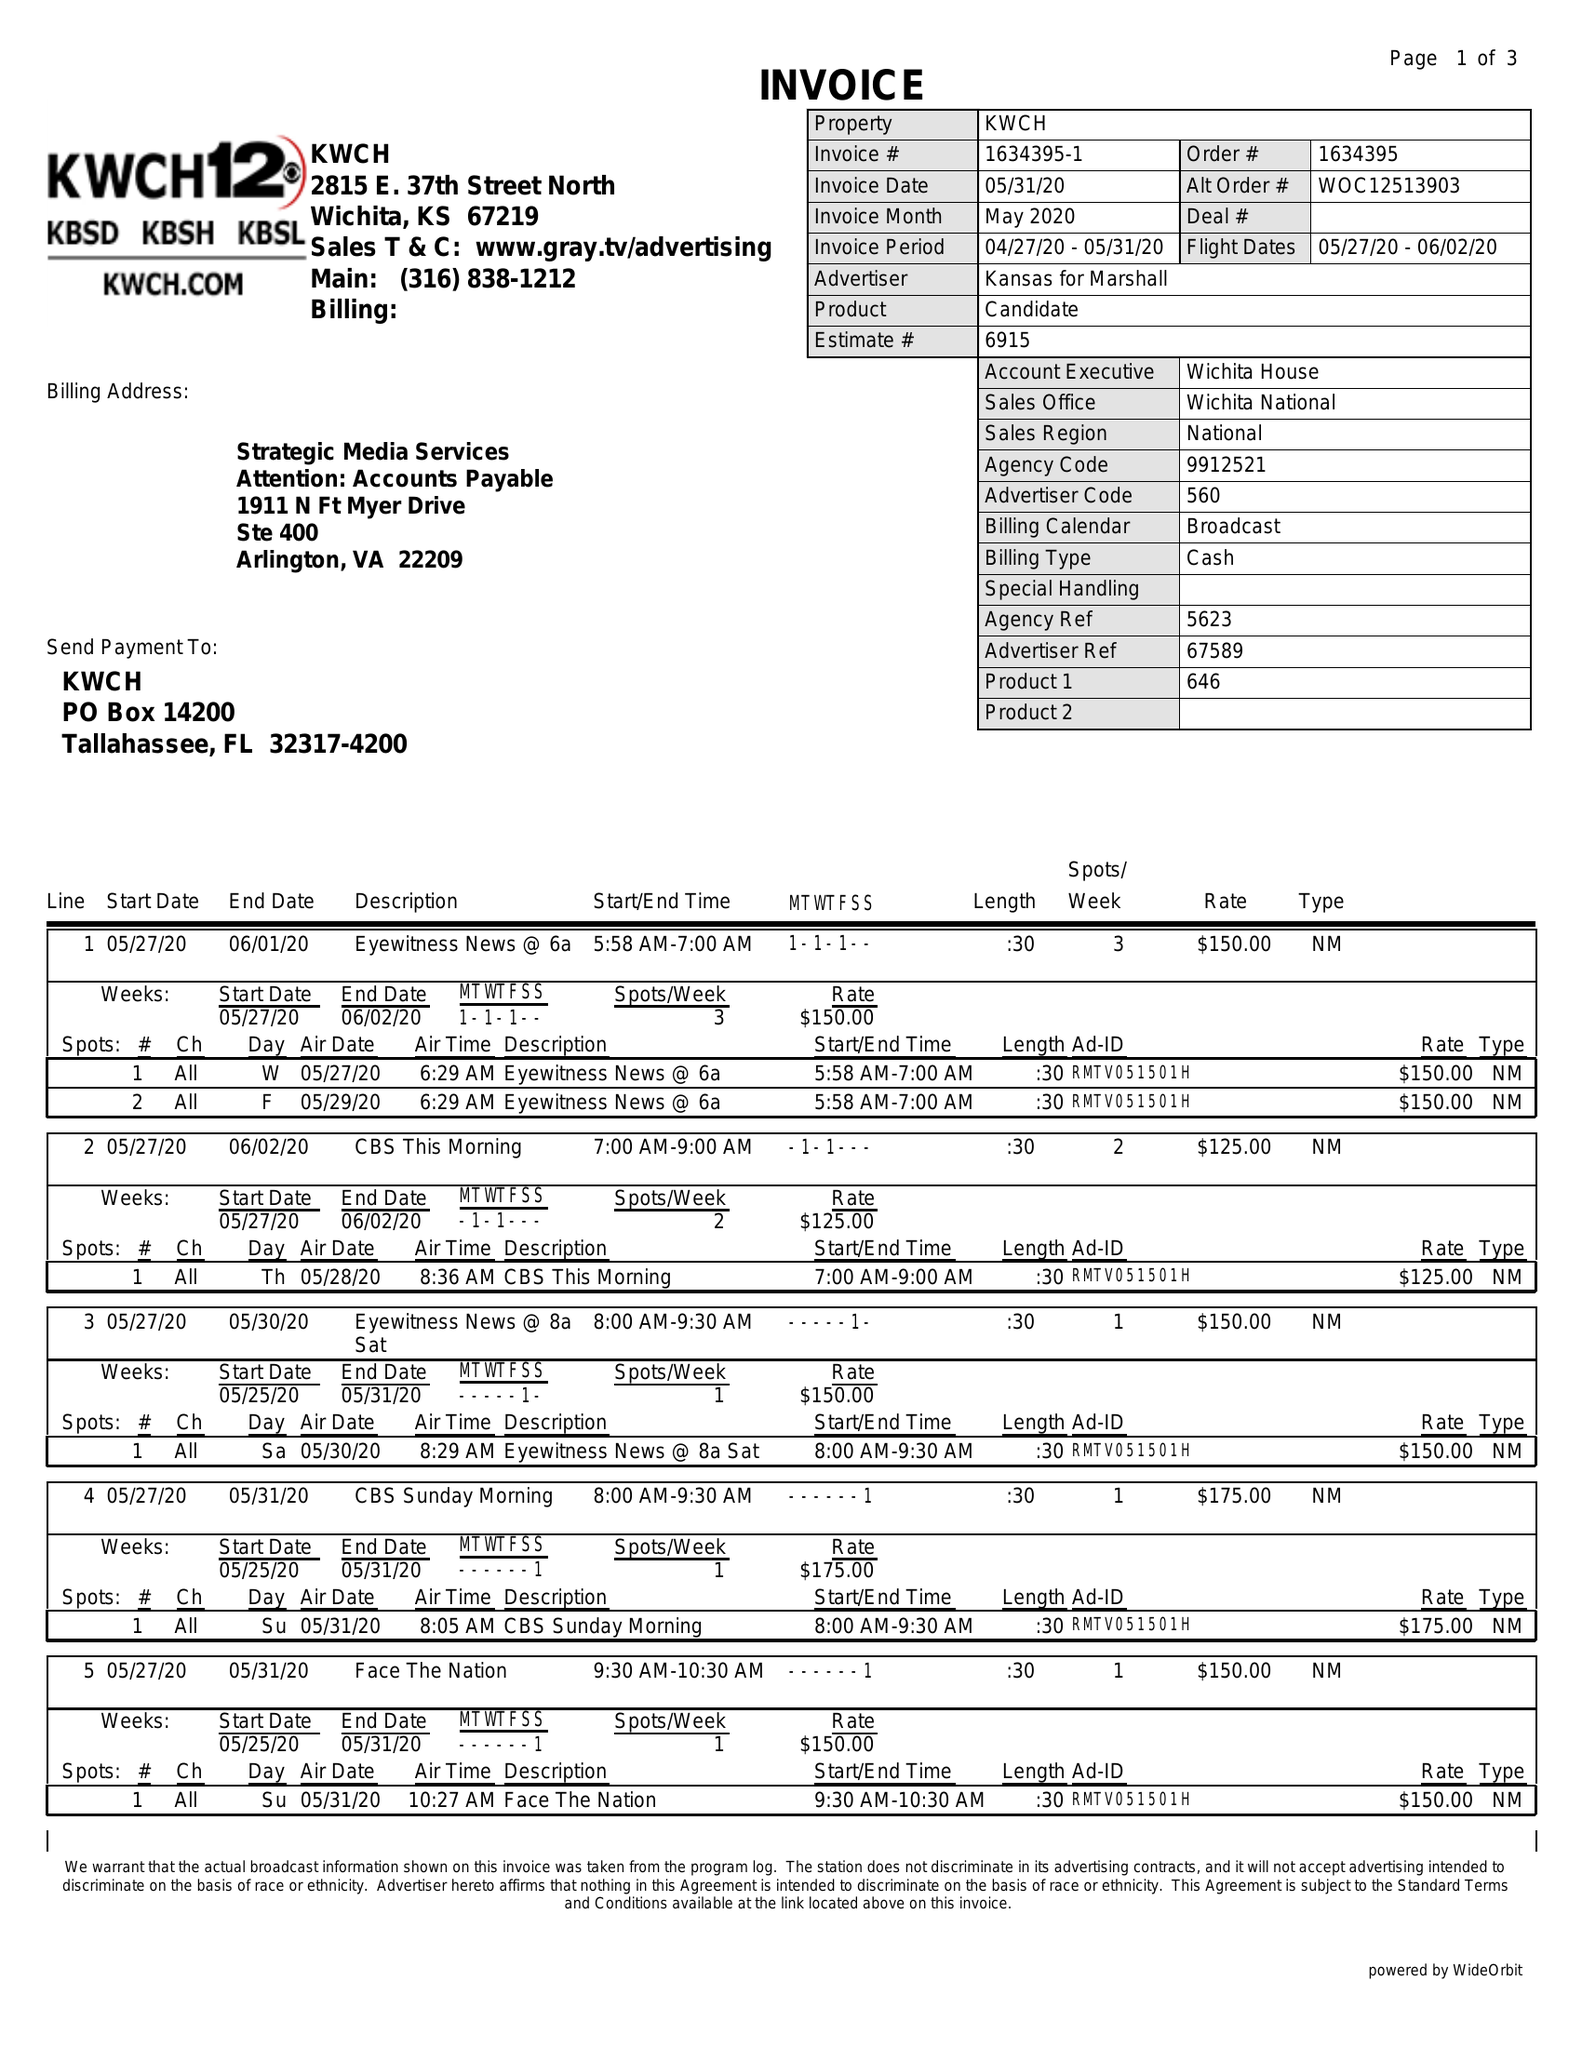What is the value for the flight_to?
Answer the question using a single word or phrase. 06/02/20 